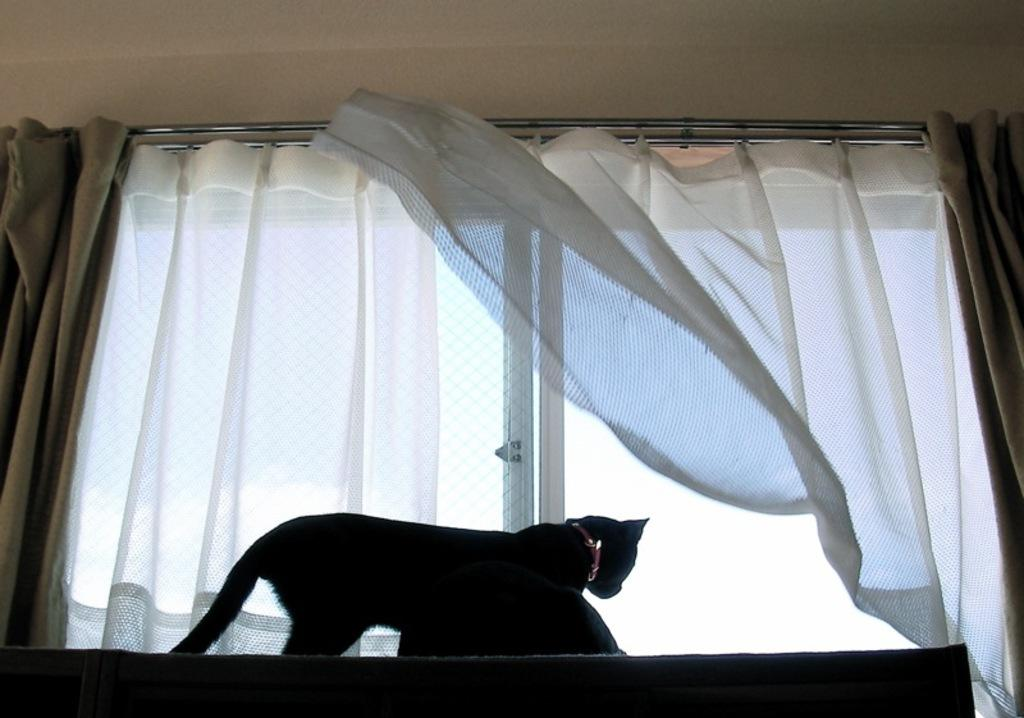How many cats are visible in the image? There are two cats on the table in the image. What is in front of the cats? There is a glass window in front of the cats. What type of window treatment is present in the image? There are curtains associated with the window. What can be seen in the background of the image? There is a wall in the background of the image. What type of toothbrush is the cat using in the image? There is no toothbrush present in the image, and the cats are not using any toothbrushes. 